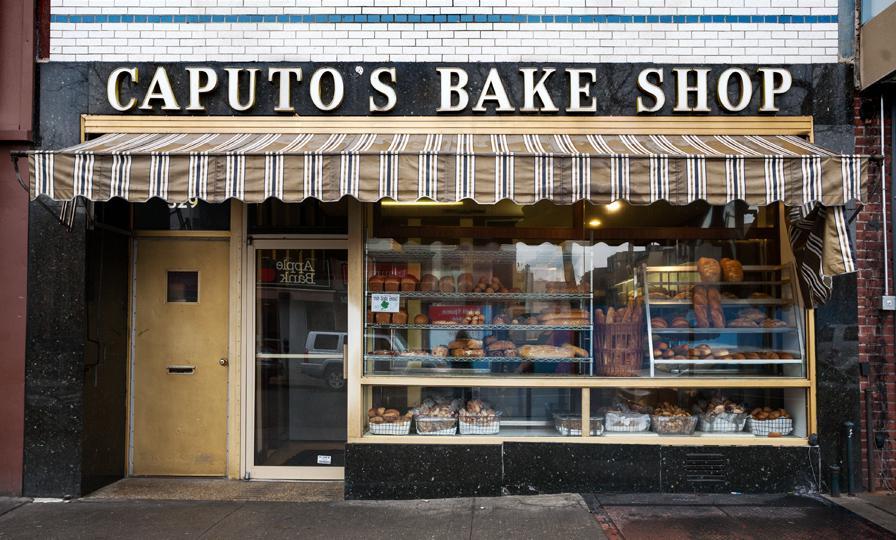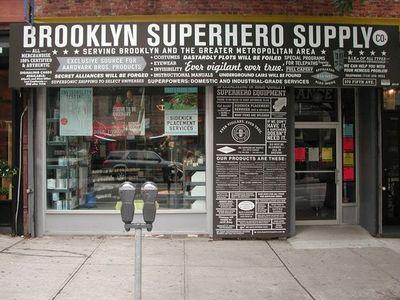The first image is the image on the left, the second image is the image on the right. For the images shown, is this caption "There is a striped awning in the image on the left." true? Answer yes or no. Yes. 